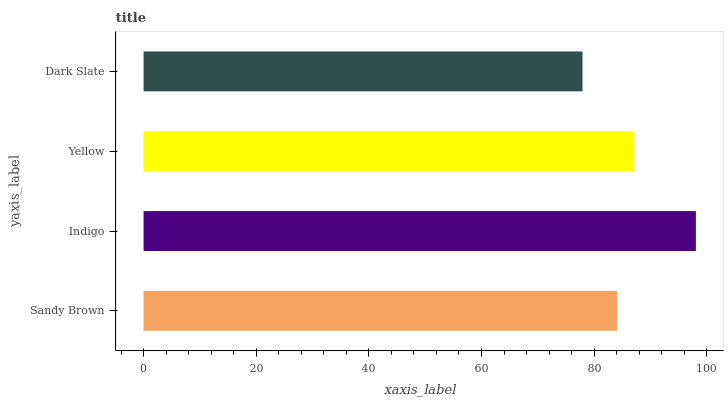Is Dark Slate the minimum?
Answer yes or no. Yes. Is Indigo the maximum?
Answer yes or no. Yes. Is Yellow the minimum?
Answer yes or no. No. Is Yellow the maximum?
Answer yes or no. No. Is Indigo greater than Yellow?
Answer yes or no. Yes. Is Yellow less than Indigo?
Answer yes or no. Yes. Is Yellow greater than Indigo?
Answer yes or no. No. Is Indigo less than Yellow?
Answer yes or no. No. Is Yellow the high median?
Answer yes or no. Yes. Is Sandy Brown the low median?
Answer yes or no. Yes. Is Dark Slate the high median?
Answer yes or no. No. Is Yellow the low median?
Answer yes or no. No. 